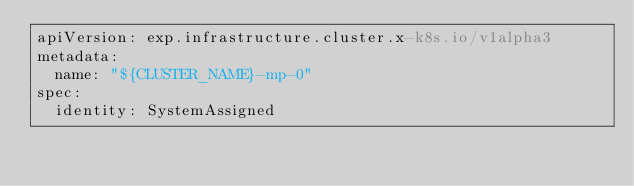<code> <loc_0><loc_0><loc_500><loc_500><_YAML_>apiVersion: exp.infrastructure.cluster.x-k8s.io/v1alpha3
metadata:
  name: "${CLUSTER_NAME}-mp-0"
spec:
  identity: SystemAssigned
</code> 